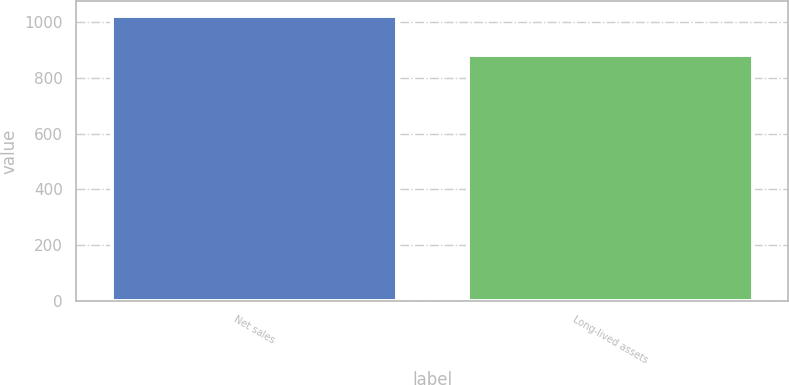Convert chart. <chart><loc_0><loc_0><loc_500><loc_500><bar_chart><fcel>Net sales<fcel>Long-lived assets<nl><fcel>1022.9<fcel>883.3<nl></chart> 